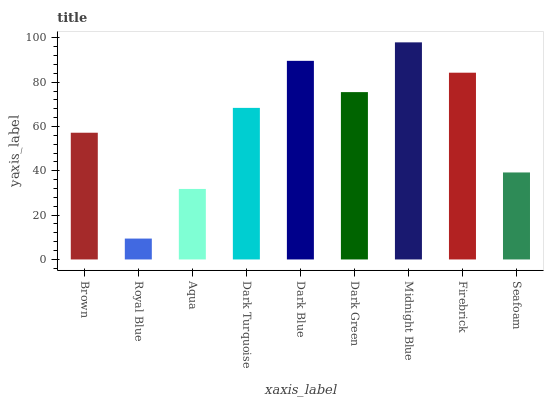Is Royal Blue the minimum?
Answer yes or no. Yes. Is Midnight Blue the maximum?
Answer yes or no. Yes. Is Aqua the minimum?
Answer yes or no. No. Is Aqua the maximum?
Answer yes or no. No. Is Aqua greater than Royal Blue?
Answer yes or no. Yes. Is Royal Blue less than Aqua?
Answer yes or no. Yes. Is Royal Blue greater than Aqua?
Answer yes or no. No. Is Aqua less than Royal Blue?
Answer yes or no. No. Is Dark Turquoise the high median?
Answer yes or no. Yes. Is Dark Turquoise the low median?
Answer yes or no. Yes. Is Aqua the high median?
Answer yes or no. No. Is Dark Blue the low median?
Answer yes or no. No. 